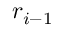<formula> <loc_0><loc_0><loc_500><loc_500>r _ { i - 1 }</formula> 